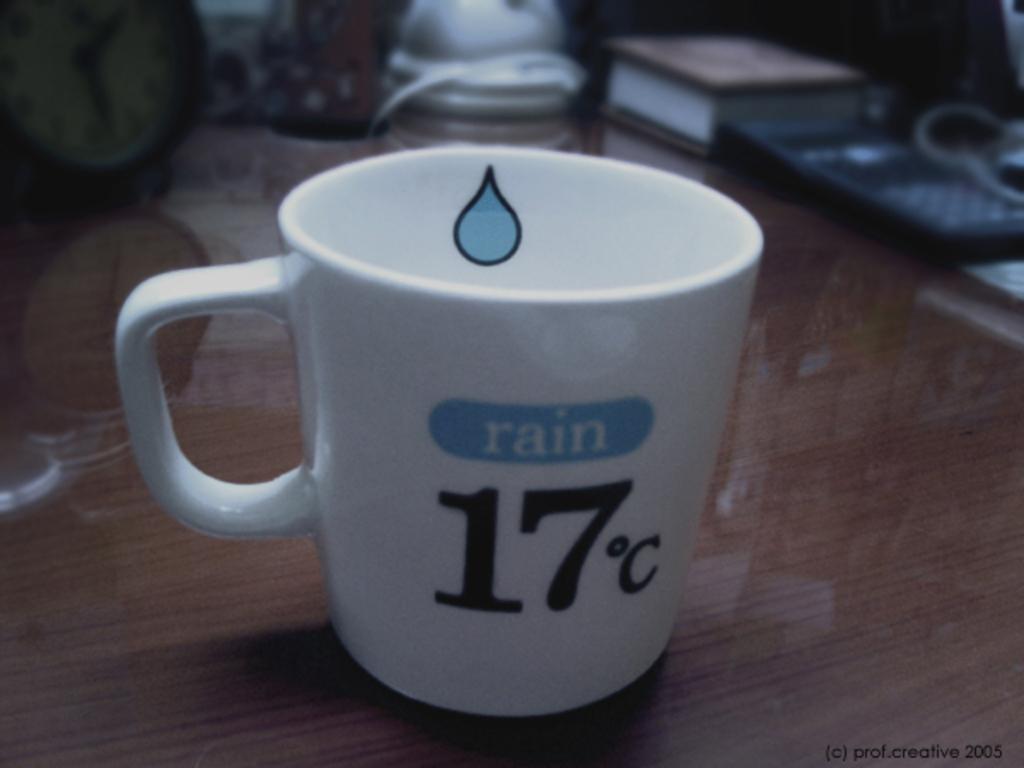What is the temperature?
Provide a succinct answer. 17c. What word is printed on this mug?
Your answer should be very brief. Rain. 